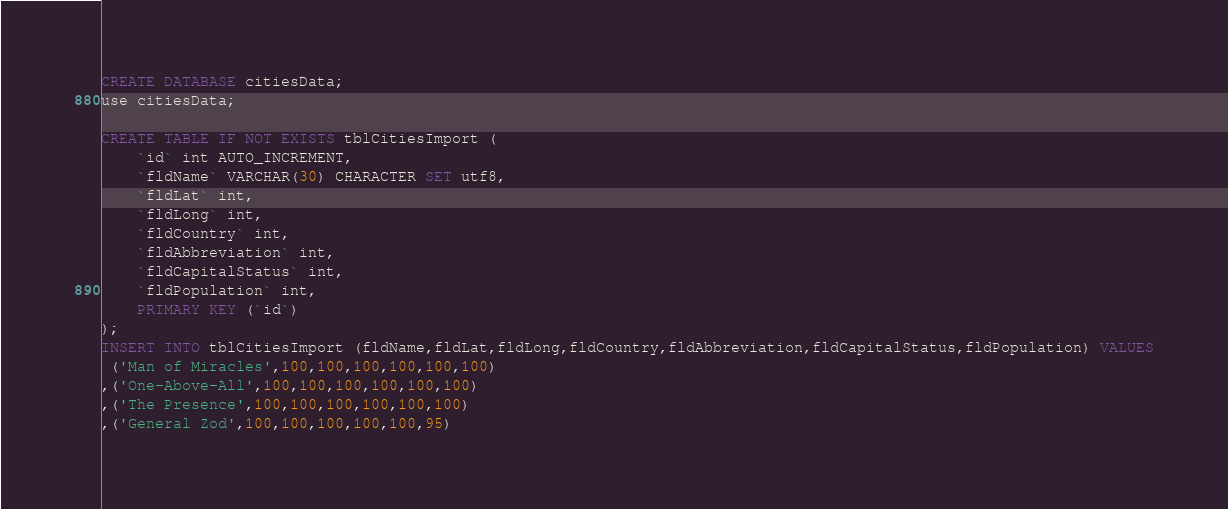Convert code to text. <code><loc_0><loc_0><loc_500><loc_500><_SQL_>CREATE DATABASE citiesData;
use citiesData;

CREATE TABLE IF NOT EXISTS tblCitiesImport (
    `id` int AUTO_INCREMENT,
    `fldName` VARCHAR(30) CHARACTER SET utf8,
    `fldLat` int,
    `fldLong` int,
    `fldCountry` int,
    `fldAbbreviation` int,
    `fldCapitalStatus` int,
    `fldPopulation` int,
    PRIMARY KEY (`id`)
);
INSERT INTO tblCitiesImport (fldName,fldLat,fldLong,fldCountry,fldAbbreviation,fldCapitalStatus,fldPopulation) VALUES
 ('Man of Miracles',100,100,100,100,100,100)
,('One-Above-All',100,100,100,100,100,100)
,('The Presence',100,100,100,100,100,100)
,('General Zod',100,100,100,100,100,95)</code> 